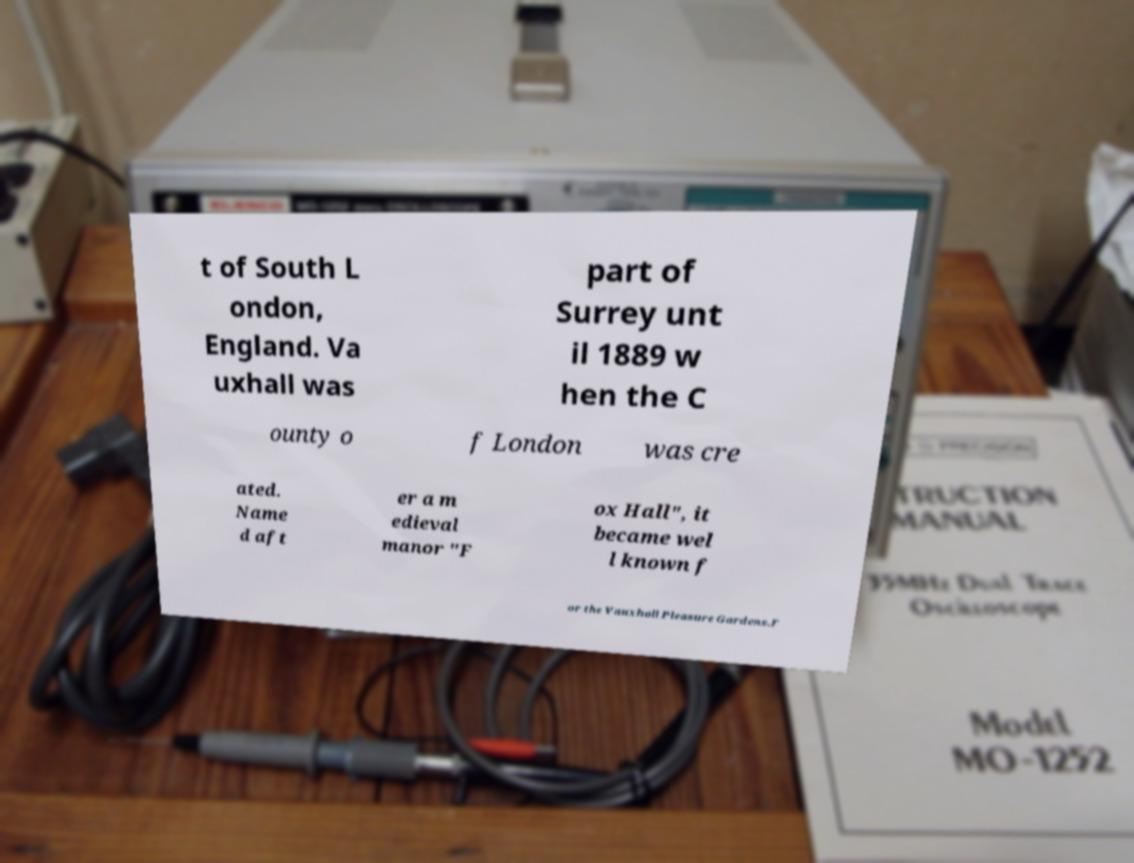Please identify and transcribe the text found in this image. t of South L ondon, England. Va uxhall was part of Surrey unt il 1889 w hen the C ounty o f London was cre ated. Name d aft er a m edieval manor "F ox Hall", it became wel l known f or the Vauxhall Pleasure Gardens.F 